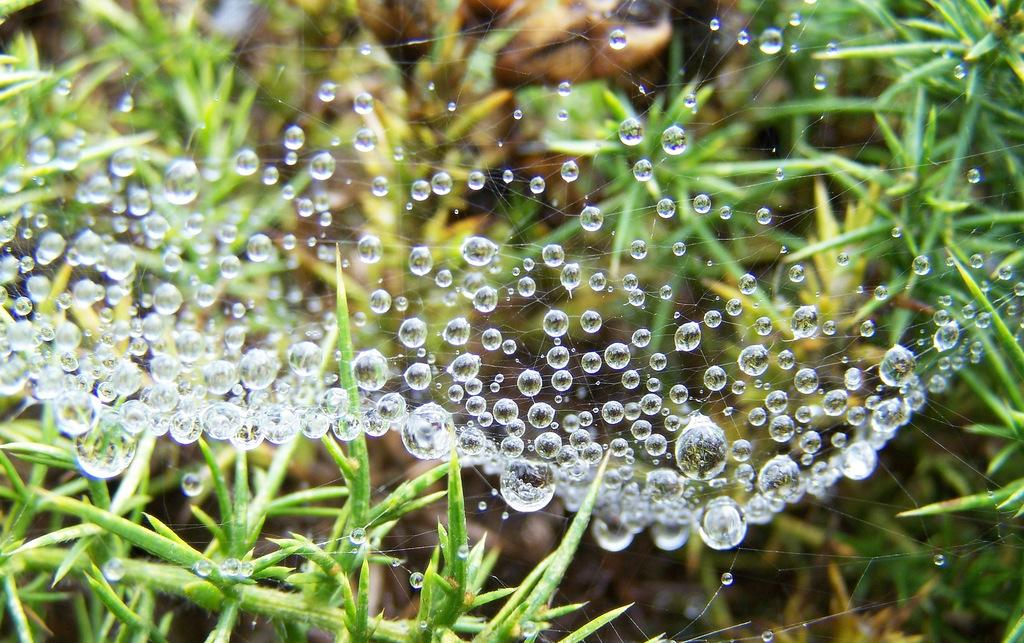What is present on the spider web in the image? There are water droplets on a spider web in the image. What type of vegetation can be seen in the image? There are plants in the image. Can you describe the background of the image? The background of the image is blurred. What type of chicken is sitting on the bag in the image? There is no chicken or bag present in the image; it features a spider web with water droplets and plants. What type of wine is being served in the image? There is no wine or serving in the image; it features a spider web with water droplets and plants. 